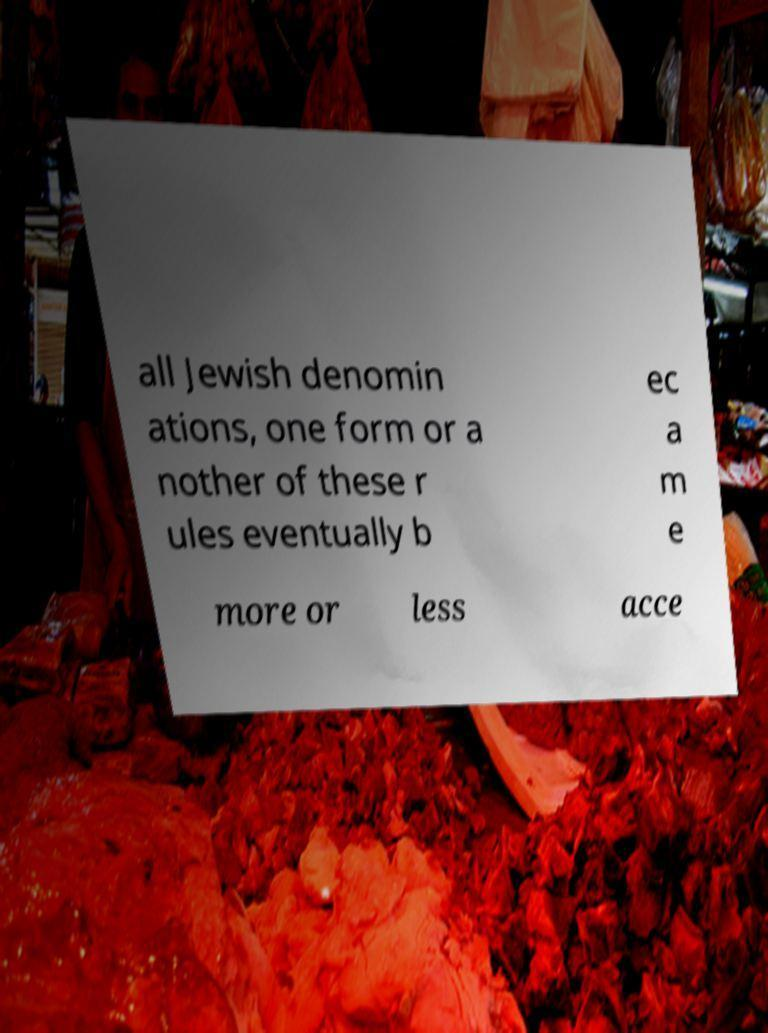For documentation purposes, I need the text within this image transcribed. Could you provide that? all Jewish denomin ations, one form or a nother of these r ules eventually b ec a m e more or less acce 